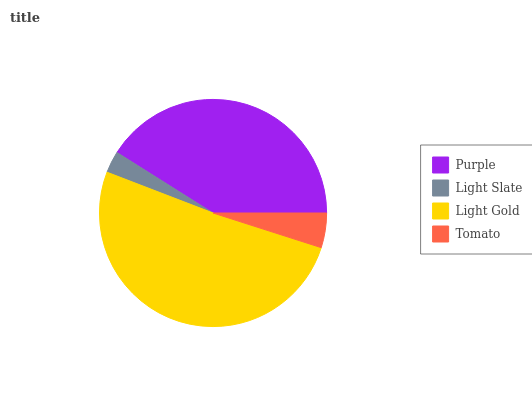Is Light Slate the minimum?
Answer yes or no. Yes. Is Light Gold the maximum?
Answer yes or no. Yes. Is Light Gold the minimum?
Answer yes or no. No. Is Light Slate the maximum?
Answer yes or no. No. Is Light Gold greater than Light Slate?
Answer yes or no. Yes. Is Light Slate less than Light Gold?
Answer yes or no. Yes. Is Light Slate greater than Light Gold?
Answer yes or no. No. Is Light Gold less than Light Slate?
Answer yes or no. No. Is Purple the high median?
Answer yes or no. Yes. Is Tomato the low median?
Answer yes or no. Yes. Is Tomato the high median?
Answer yes or no. No. Is Light Slate the low median?
Answer yes or no. No. 